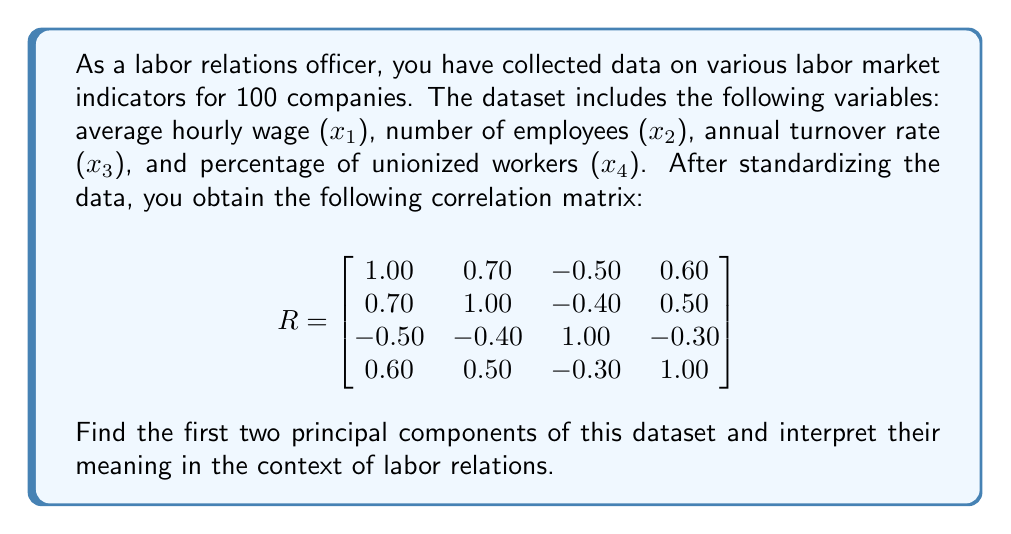What is the answer to this math problem? To find the principal components, we need to perform the following steps:

1. Calculate the eigenvalues and eigenvectors of the correlation matrix $R$.

2. The eigenvalues $\lambda$ are found by solving the characteristic equation:
   $\det(R - \lambda I) = 0$

3. Using a numerical method or software, we find the eigenvalues:
   $\lambda_1 \approx 2.5245$
   $\lambda_2 \approx 0.8234$
   $\lambda_3 \approx 0.3910$
   $\lambda_4 \approx 0.2611$

4. The corresponding eigenvectors are:
   $v_1 \approx [0.5499, 0.5152, -0.4124, 0.5099]^T$
   $v_2 \approx [-0.1459, -0.2517, -0.9007, 0.3164]^T$

5. The first two principal components (PC) are:
   PC1 = $0.5499x_1 + 0.5152x_2 - 0.4124x_3 + 0.5099x_4$
   PC2 = $-0.1459x_1 - 0.2517x_2 - 0.9007x_3 + 0.3164x_4$

6. Interpretation:
   - PC1 accounts for 63.11% of the total variance ($2.5245 / 4$).
   - PC2 accounts for 20.59% of the total variance ($0.8234 / 4$).
   
   PC1 has positive loadings for wages, number of employees, and unionization, and a negative loading for turnover. This component represents overall labor stability and strength.
   
   PC2 has a large negative loading for turnover and smaller positive loadings for unionization. This component primarily contrasts turnover with other factors, particularly unionization.

In the context of labor relations, PC1 could be interpreted as a measure of workforce stability and bargaining power, while PC2 might represent employee retention and union influence.
Answer: PC1 = $0.5499x_1 + 0.5152x_2 - 0.4124x_3 + 0.5099x_4$ (workforce stability and bargaining power)
PC2 = $-0.1459x_1 - 0.2517x_2 - 0.9007x_3 + 0.3164x_4$ (employee retention and union influence) 